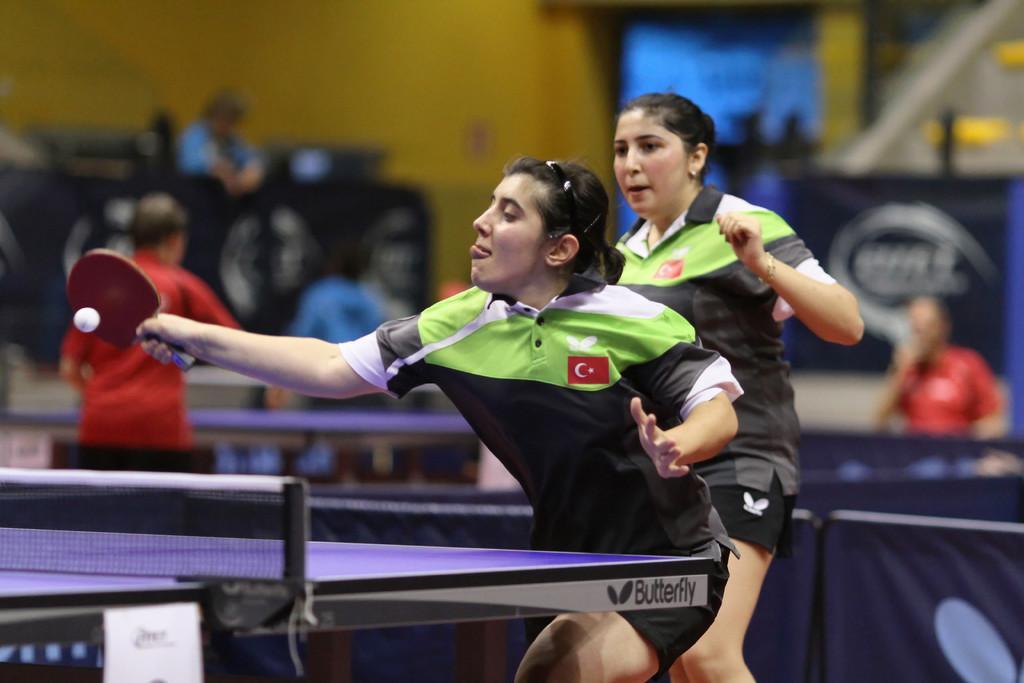Please provide a concise description of this image. Here we can see two women playing table tennis and the women in the front is having the bat and she is hitting to ball and behind them we can see people standing 